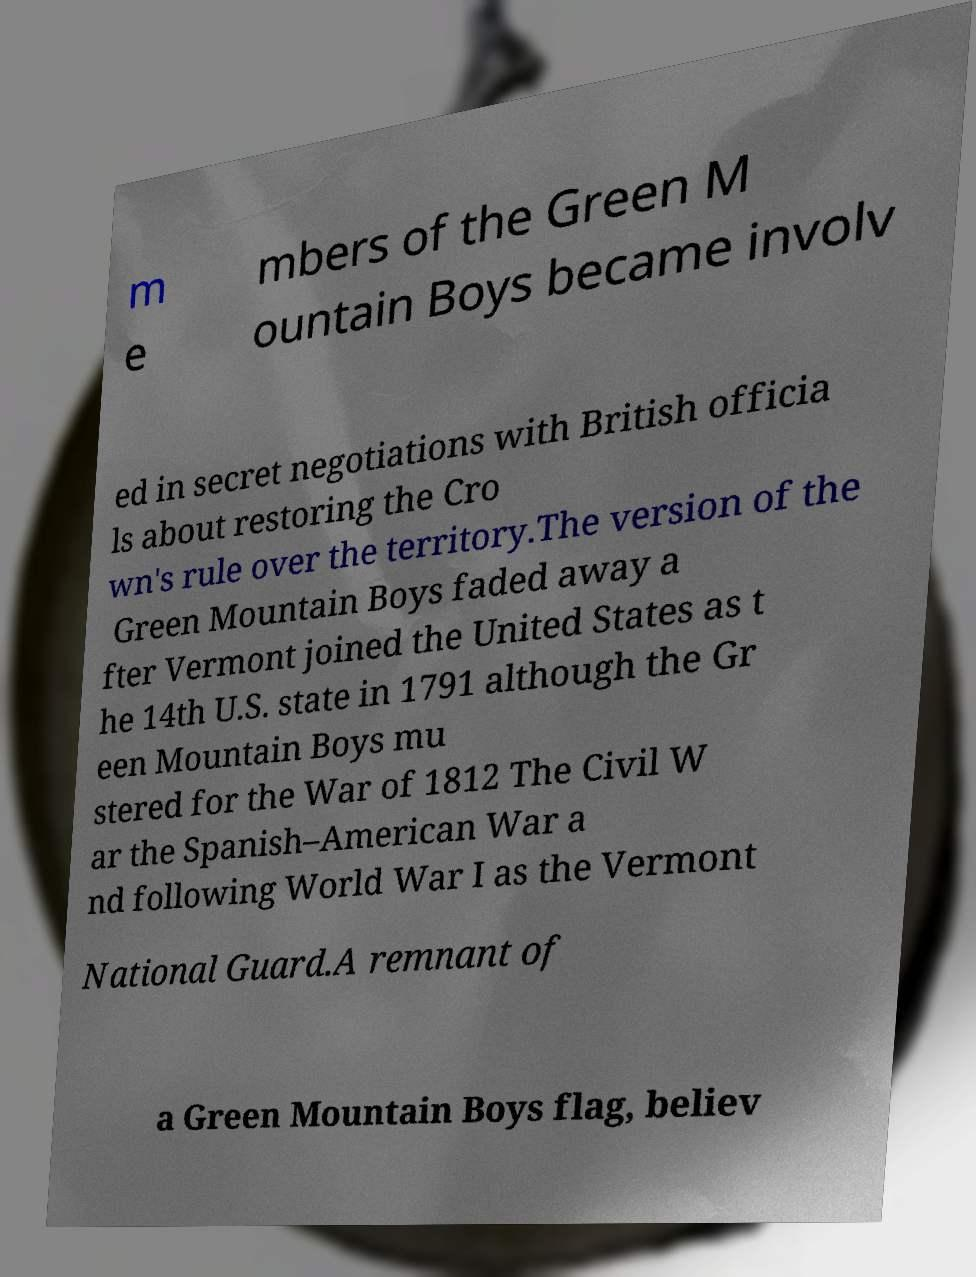Can you accurately transcribe the text from the provided image for me? m e mbers of the Green M ountain Boys became involv ed in secret negotiations with British officia ls about restoring the Cro wn's rule over the territory.The version of the Green Mountain Boys faded away a fter Vermont joined the United States as t he 14th U.S. state in 1791 although the Gr een Mountain Boys mu stered for the War of 1812 The Civil W ar the Spanish–American War a nd following World War I as the Vermont National Guard.A remnant of a Green Mountain Boys flag, believ 